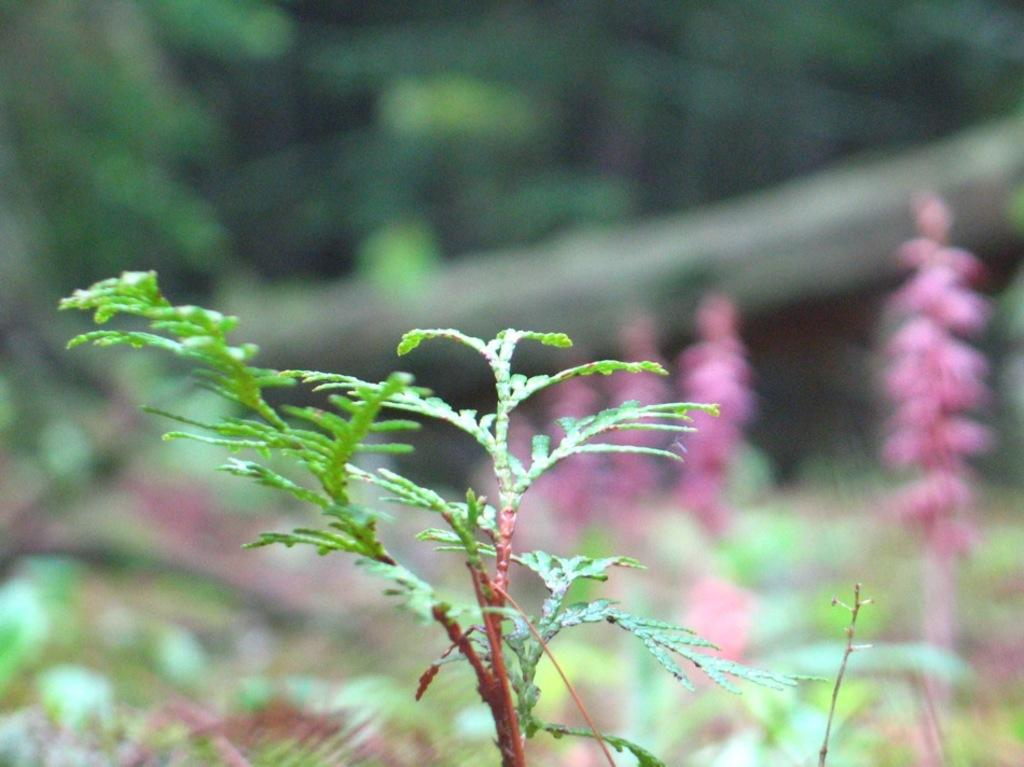What type of plant is located at the bottom of the image? There is a plant with green leaves at the bottom of the image. What other plants can be seen in the image? There are plants with pink flowers in the background of the image. How would you describe the background of the image? The background is blurred. How many brothers are playing with the plant in the image? There are no brothers present in the image, and the plant is not being played with. 